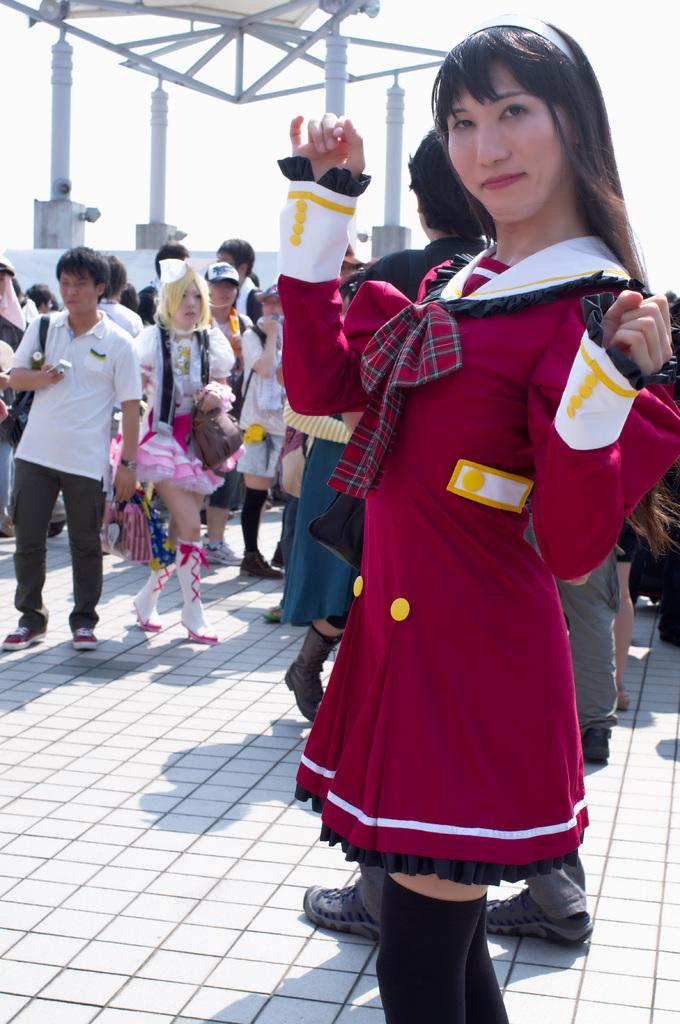What is the main subject in the image? There is a woman standing in the image. Are there any other people in the image? Yes, there is a group of people standing in the image. What type of structure is visible in the image? There is a wall in the image, along with pillars and metal poles. What can be seen in the sky in the image? The sky is visible in the image. What type of trucks can be seen in the image? There are no trucks present in the image. How many girls are visible in the image? The image does not specify the gender of the people present, so it is not possible to determine the number of girls. 